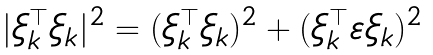Convert formula to latex. <formula><loc_0><loc_0><loc_500><loc_500>| \xi ^ { \top } _ { k } \xi _ { k } | ^ { 2 } = ( \xi ^ { \top } _ { k } \xi _ { k } ) ^ { 2 } + ( \xi ^ { \top } _ { k } { \boldsymbol \varepsilon } \xi _ { k } ) ^ { 2 }</formula> 